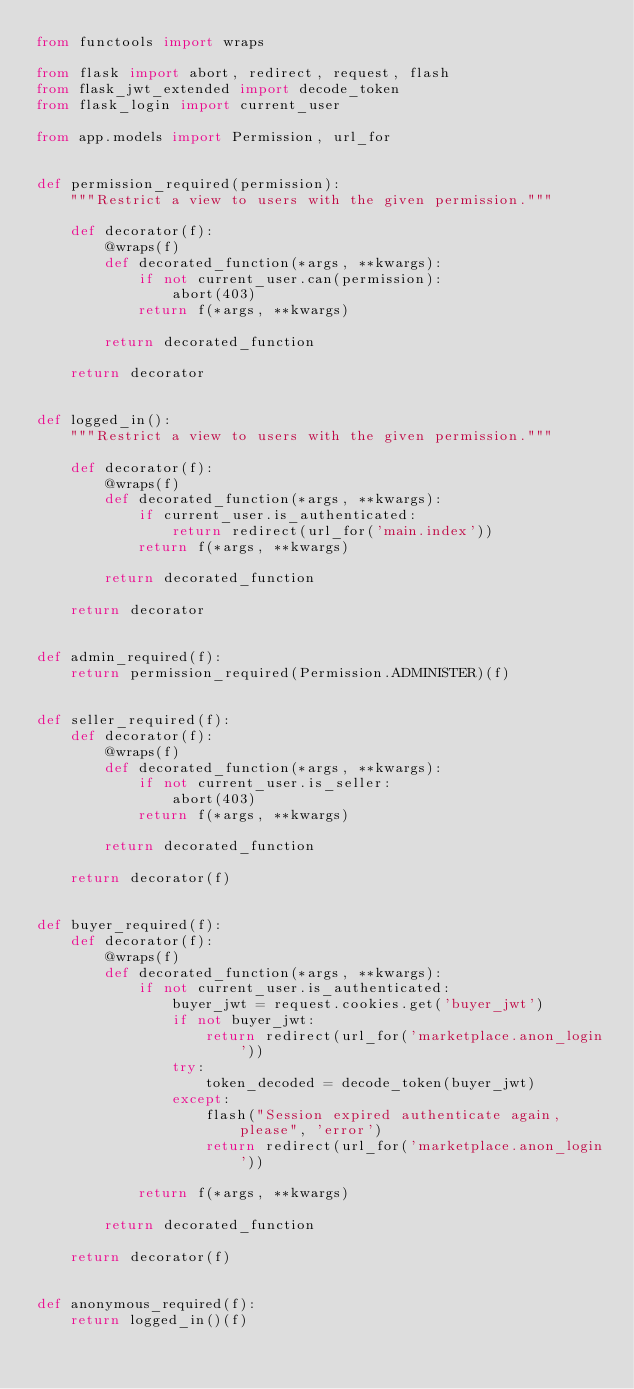Convert code to text. <code><loc_0><loc_0><loc_500><loc_500><_Python_>from functools import wraps

from flask import abort, redirect, request, flash
from flask_jwt_extended import decode_token
from flask_login import current_user

from app.models import Permission, url_for


def permission_required(permission):
    """Restrict a view to users with the given permission."""

    def decorator(f):
        @wraps(f)
        def decorated_function(*args, **kwargs):
            if not current_user.can(permission):
                abort(403)
            return f(*args, **kwargs)

        return decorated_function

    return decorator


def logged_in():
    """Restrict a view to users with the given permission."""

    def decorator(f):
        @wraps(f)
        def decorated_function(*args, **kwargs):
            if current_user.is_authenticated:
                return redirect(url_for('main.index'))
            return f(*args, **kwargs)

        return decorated_function

    return decorator


def admin_required(f):
    return permission_required(Permission.ADMINISTER)(f)


def seller_required(f):
    def decorator(f):
        @wraps(f)
        def decorated_function(*args, **kwargs):
            if not current_user.is_seller:
                abort(403)
            return f(*args, **kwargs)

        return decorated_function

    return decorator(f)


def buyer_required(f):
    def decorator(f):
        @wraps(f)
        def decorated_function(*args, **kwargs):
            if not current_user.is_authenticated:
                buyer_jwt = request.cookies.get('buyer_jwt')
                if not buyer_jwt:
                    return redirect(url_for('marketplace.anon_login'))
                try:
                    token_decoded = decode_token(buyer_jwt)
                except:
                    flash("Session expired authenticate again, please", 'error')
                    return redirect(url_for('marketplace.anon_login'))

            return f(*args, **kwargs)

        return decorated_function

    return decorator(f)


def anonymous_required(f):
    return logged_in()(f)
</code> 